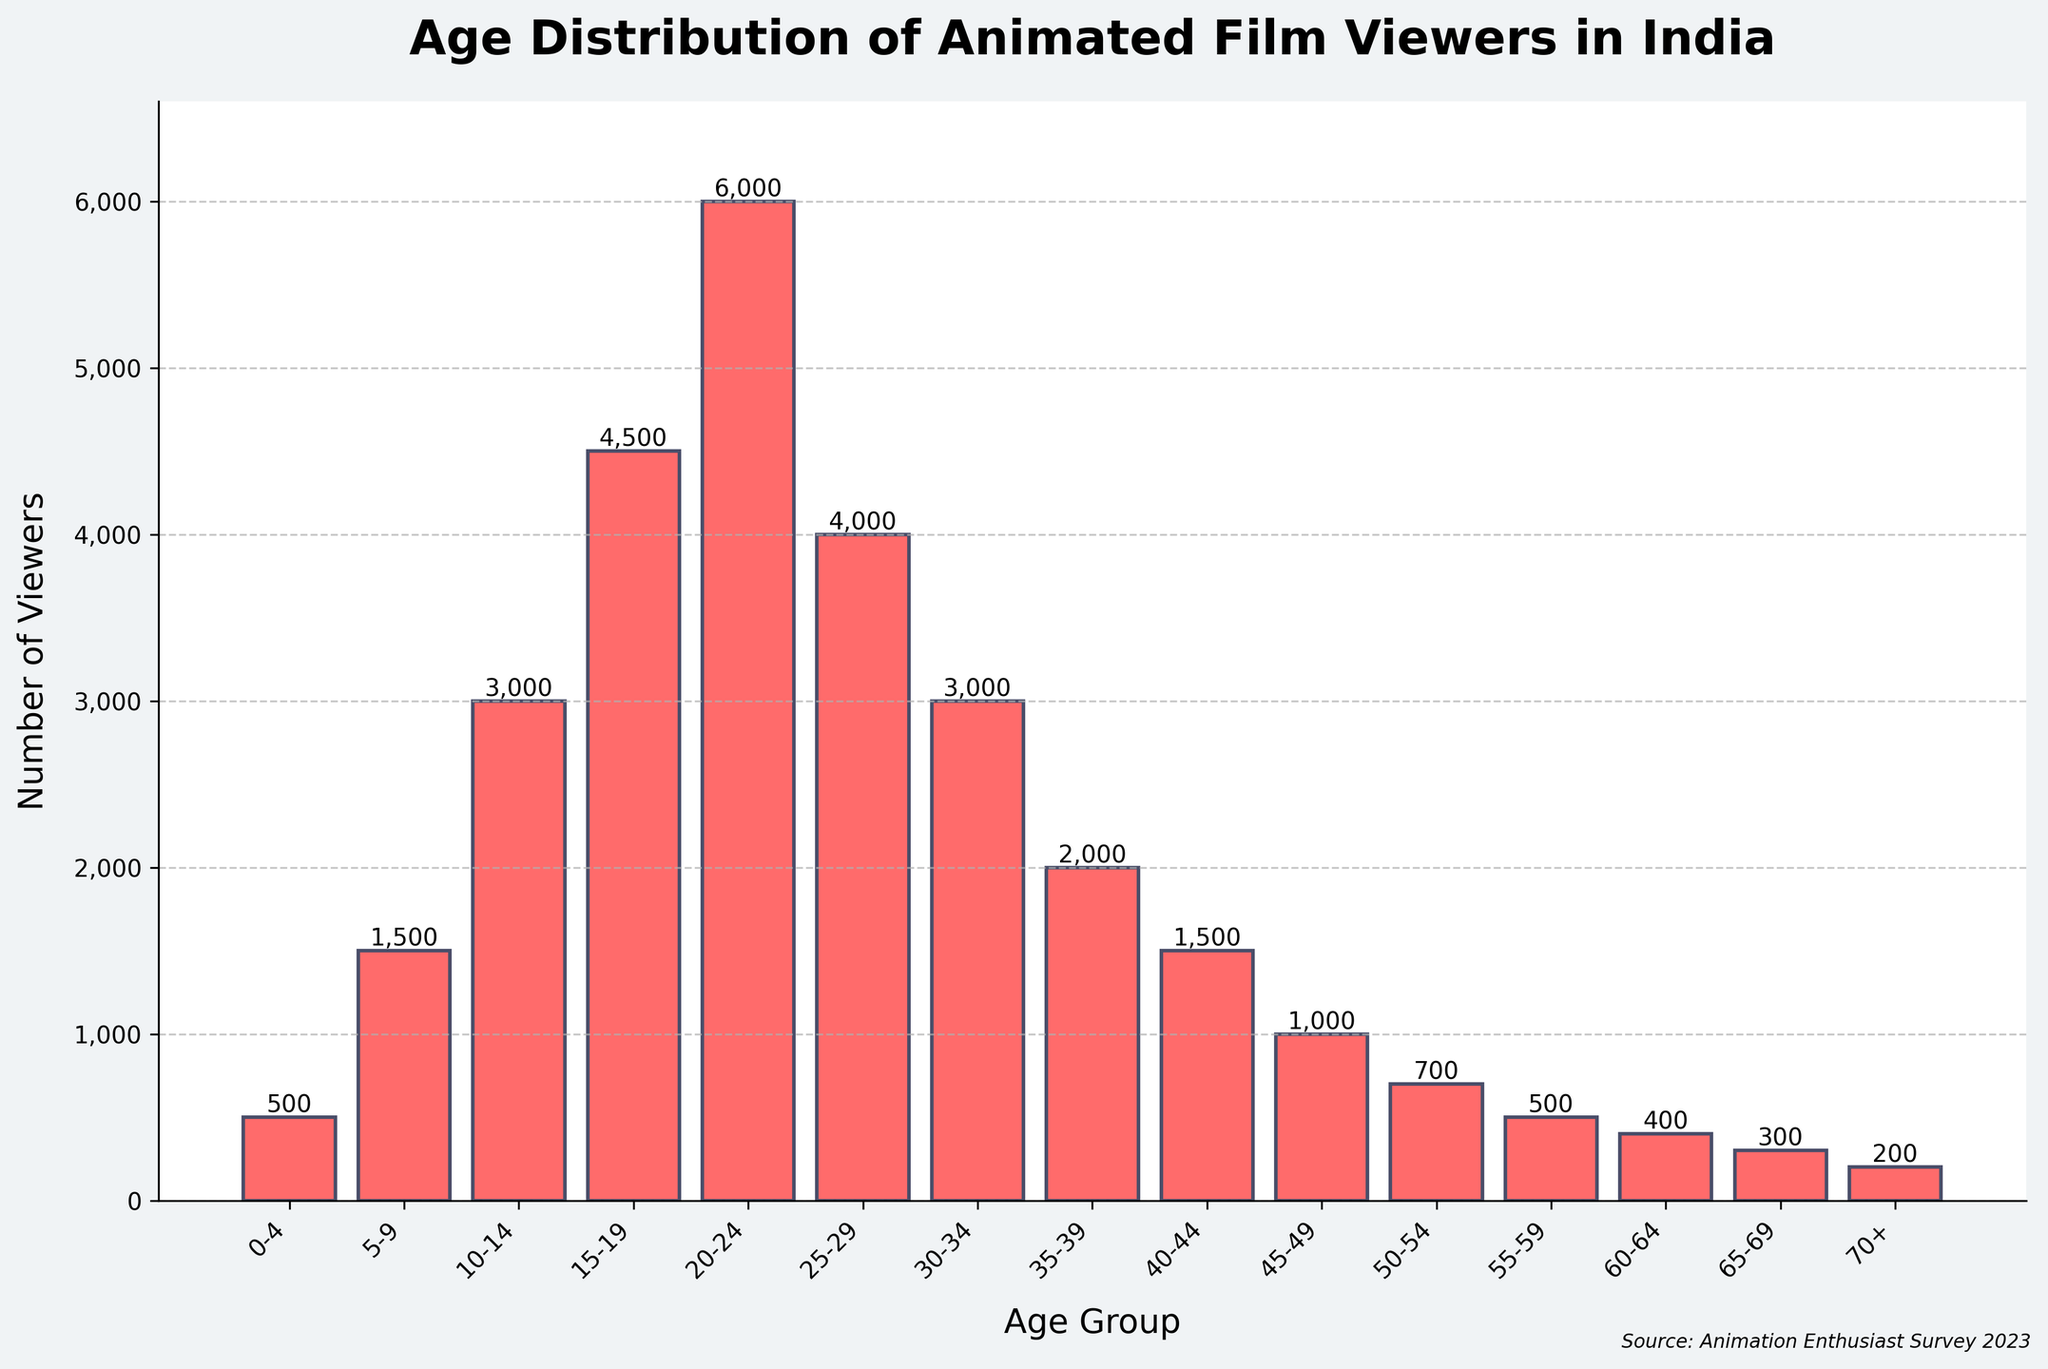What is the title of the plot? The title of the plot is displayed prominently at the top of the figure in a larger and bold font. It reads "Age Distribution of Animated Film Viewers in India".
Answer: Age Distribution of Animated Film Viewers in India Which age group has the highest number of viewers? By examining the heights of the bars, the highest one represents the age group 20-24. This group has the largest number of viewers in the plot.
Answer: 20-24 What is the number of viewers in the 70+ age group? The bar corresponding to the 70+ age group reaches up to a height marked with the number label 200.
Answer: 200 Which age groups have viewers in the range of 1000 to 2000? We need to locate bars with heights between 1000 and 2000 viewers. These bars correspond to the age groups 5-9, 35-39, 40-44, and 45-49.
Answer: 5-9, 35-39, 40-44, 45-49 How many age groups are represented in the plot? Count the individual bars displayed in the figure. Each bar corresponds to one age group. There are 15 bars in total, indicating that there are 15 different age groups.
Answer: 15 What is the combined number of viewers in the age groups 25-29 and 30-34? Add the number of viewers for the age groups 25-29 (4000) and 30-34 (3000). The combined number is 4000 + 3000 = 7000.
Answer: 7000 Which age group has fewer viewers: 10-14 or 45-49? Compare the heights of the bars for the 10-14 and 45-49 age groups. The bar for 10-14 is higher with 3000 viewers, while the bar for 45-49 is lower with 1000 viewers, so 45-49 has fewer viewers.
Answer: 45-49 What is the total number of viewers for age groups under 10 years old? Sum the number of viewers in the age groups 0-4 and 5-9. So, 500 (0-4) + 1500 (5-9) = 2000 viewers.
Answer: 2000 What is the average number of viewers across all age groups? Sum the total number of viewers across all age groups and divide by the number of age groups. The total viewers are 30000, and there are 15 age groups, so the average is 30000 / 15 = 2000.
Answer: 2000 Which age group has more viewers: 50-54 or 55-59? Compare the heights of the bars for the 50-54 and 55-59 age groups. The bar for 50-54 shows 700 viewers, and the bar for 55-59 shows 500 viewers, indicating 50-54 has more viewers.
Answer: 50-54 